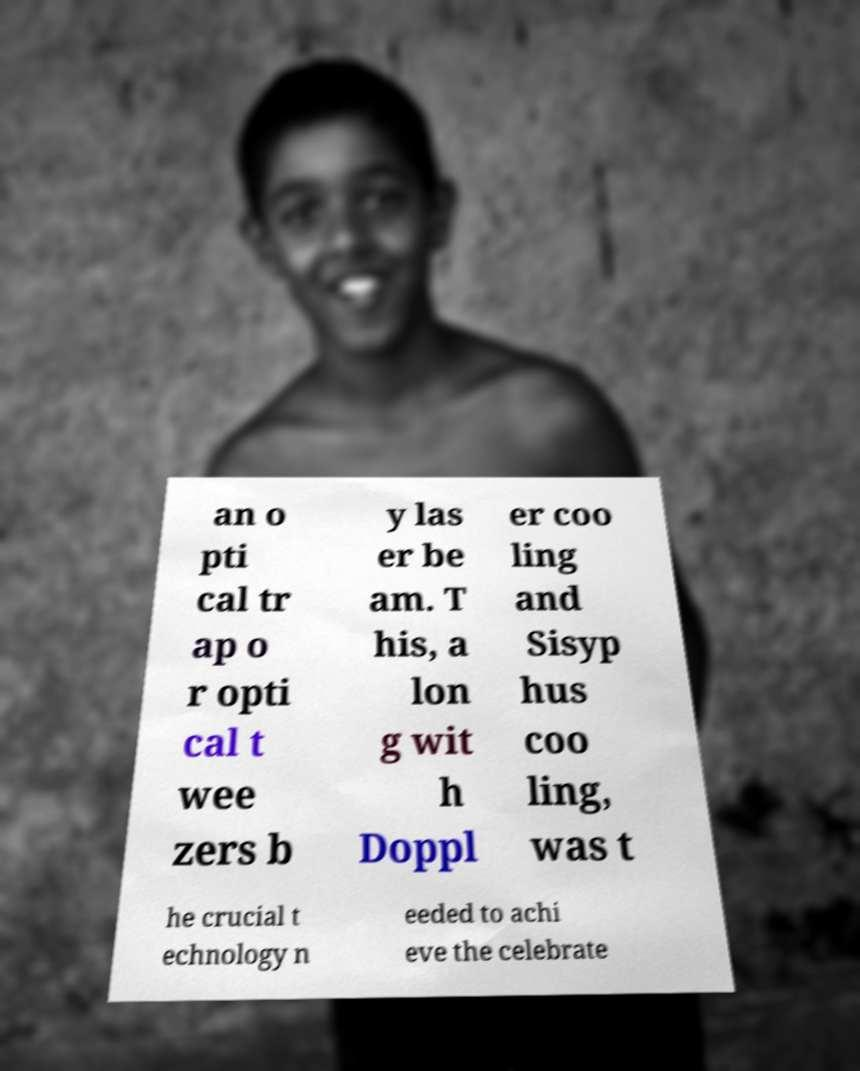Please identify and transcribe the text found in this image. an o pti cal tr ap o r opti cal t wee zers b y las er be am. T his, a lon g wit h Doppl er coo ling and Sisyp hus coo ling, was t he crucial t echnology n eeded to achi eve the celebrate 